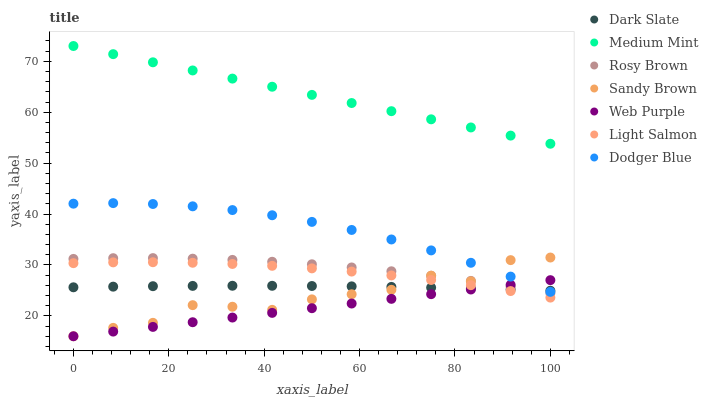Does Web Purple have the minimum area under the curve?
Answer yes or no. Yes. Does Medium Mint have the maximum area under the curve?
Answer yes or no. Yes. Does Light Salmon have the minimum area under the curve?
Answer yes or no. No. Does Light Salmon have the maximum area under the curve?
Answer yes or no. No. Is Web Purple the smoothest?
Answer yes or no. Yes. Is Sandy Brown the roughest?
Answer yes or no. Yes. Is Light Salmon the smoothest?
Answer yes or no. No. Is Light Salmon the roughest?
Answer yes or no. No. Does Web Purple have the lowest value?
Answer yes or no. Yes. Does Light Salmon have the lowest value?
Answer yes or no. No. Does Medium Mint have the highest value?
Answer yes or no. Yes. Does Light Salmon have the highest value?
Answer yes or no. No. Is Sandy Brown less than Medium Mint?
Answer yes or no. Yes. Is Dodger Blue greater than Light Salmon?
Answer yes or no. Yes. Does Sandy Brown intersect Dark Slate?
Answer yes or no. Yes. Is Sandy Brown less than Dark Slate?
Answer yes or no. No. Is Sandy Brown greater than Dark Slate?
Answer yes or no. No. Does Sandy Brown intersect Medium Mint?
Answer yes or no. No. 